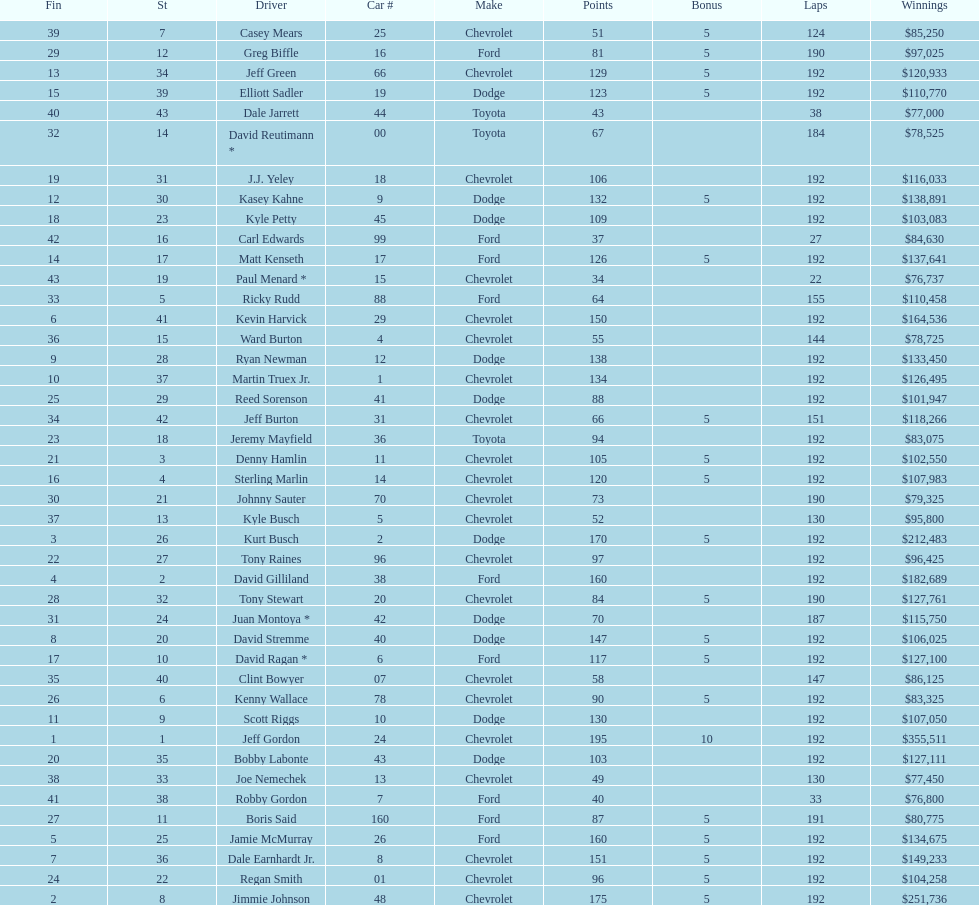Who got the most bonus points? Jeff Gordon. 